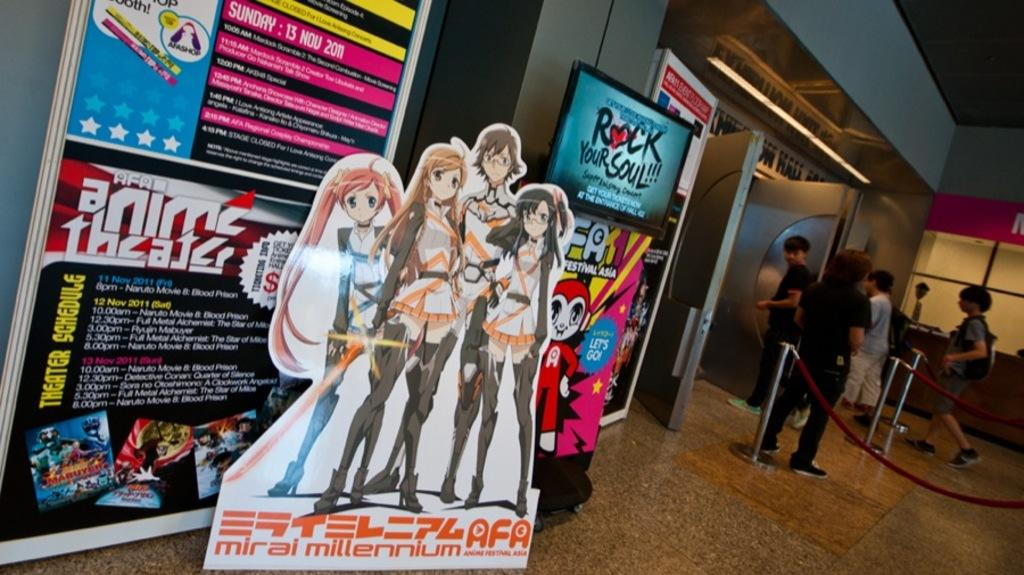<image>
Write a terse but informative summary of the picture. Anime poster sign outside of a store that says "Mirai Millennium". 